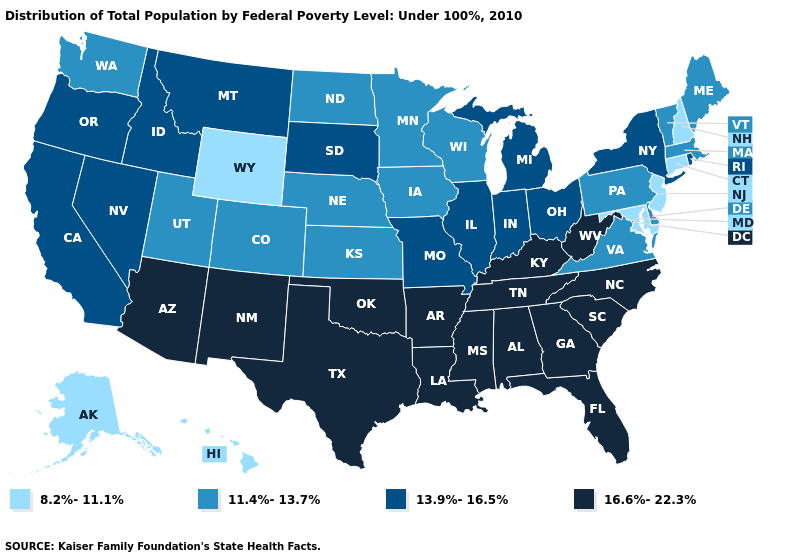Name the states that have a value in the range 8.2%-11.1%?
Concise answer only. Alaska, Connecticut, Hawaii, Maryland, New Hampshire, New Jersey, Wyoming. Is the legend a continuous bar?
Keep it brief. No. Name the states that have a value in the range 8.2%-11.1%?
Concise answer only. Alaska, Connecticut, Hawaii, Maryland, New Hampshire, New Jersey, Wyoming. Among the states that border North Carolina , does Virginia have the highest value?
Give a very brief answer. No. Does the map have missing data?
Keep it brief. No. What is the value of Oklahoma?
Answer briefly. 16.6%-22.3%. Does Hawaii have the lowest value in the USA?
Be succinct. Yes. Name the states that have a value in the range 16.6%-22.3%?
Be succinct. Alabama, Arizona, Arkansas, Florida, Georgia, Kentucky, Louisiana, Mississippi, New Mexico, North Carolina, Oklahoma, South Carolina, Tennessee, Texas, West Virginia. Among the states that border West Virginia , does Virginia have the highest value?
Keep it brief. No. Among the states that border North Dakota , which have the lowest value?
Keep it brief. Minnesota. Does New Mexico have the highest value in the West?
Write a very short answer. Yes. What is the value of Georgia?
Short answer required. 16.6%-22.3%. What is the highest value in the USA?
Concise answer only. 16.6%-22.3%. Name the states that have a value in the range 16.6%-22.3%?
Concise answer only. Alabama, Arizona, Arkansas, Florida, Georgia, Kentucky, Louisiana, Mississippi, New Mexico, North Carolina, Oklahoma, South Carolina, Tennessee, Texas, West Virginia. What is the value of Arizona?
Concise answer only. 16.6%-22.3%. 